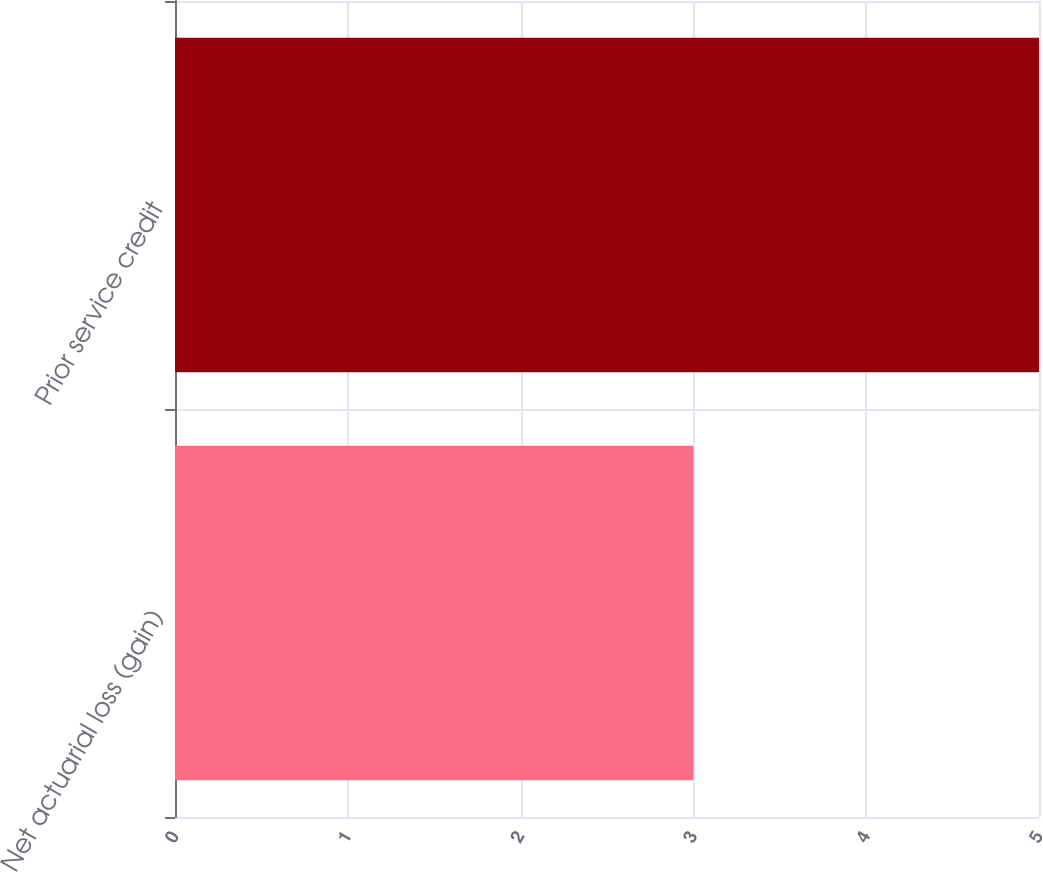Convert chart. <chart><loc_0><loc_0><loc_500><loc_500><bar_chart><fcel>Net actuarial loss (gain)<fcel>Prior service credit<nl><fcel>3<fcel>5<nl></chart> 